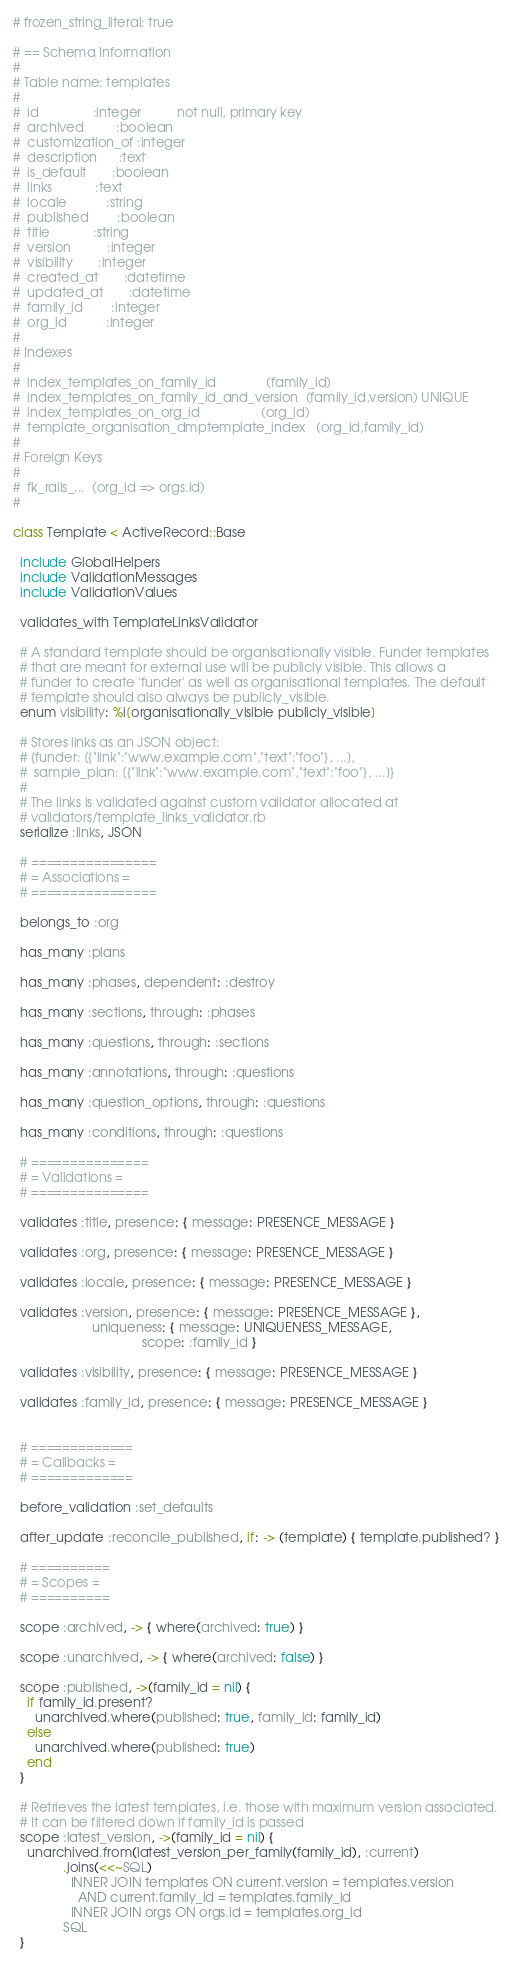<code> <loc_0><loc_0><loc_500><loc_500><_Ruby_># frozen_string_literal: true

# == Schema Information
#
# Table name: templates
#
#  id               :integer          not null, primary key
#  archived         :boolean
#  customization_of :integer
#  description      :text
#  is_default       :boolean
#  links            :text
#  locale           :string
#  published        :boolean
#  title            :string
#  version          :integer
#  visibility       :integer
#  created_at       :datetime
#  updated_at       :datetime
#  family_id        :integer
#  org_id           :integer
#
# Indexes
#
#  index_templates_on_family_id              (family_id)
#  index_templates_on_family_id_and_version  (family_id,version) UNIQUE
#  index_templates_on_org_id                 (org_id)
#  template_organisation_dmptemplate_index   (org_id,family_id)
#
# Foreign Keys
#
#  fk_rails_...  (org_id => orgs.id)
#

class Template < ActiveRecord::Base

  include GlobalHelpers
  include ValidationMessages
  include ValidationValues

  validates_with TemplateLinksValidator

  # A standard template should be organisationally visible. Funder templates
  # that are meant for external use will be publicly visible. This allows a
  # funder to create 'funder' as well as organisational templates. The default
  # template should also always be publicly_visible.
  enum visibility: %i[organisationally_visible publicly_visible]

  # Stores links as an JSON object:
  # {funder: [{"link":"www.example.com","text":"foo"}, ...],
  #  sample_plan: [{"link":"www.example.com","text":"foo"}, ...]}
  #
  # The links is validated against custom validator allocated at
  # validators/template_links_validator.rb
  serialize :links, JSON

  # ================
  # = Associations =
  # ================

  belongs_to :org

  has_many :plans

  has_many :phases, dependent: :destroy

  has_many :sections, through: :phases

  has_many :questions, through: :sections

  has_many :annotations, through: :questions

  has_many :question_options, through: :questions

  has_many :conditions, through: :questions

  # ===============
  # = Validations =
  # ===============

  validates :title, presence: { message: PRESENCE_MESSAGE }

  validates :org, presence: { message: PRESENCE_MESSAGE }

  validates :locale, presence: { message: PRESENCE_MESSAGE }

  validates :version, presence: { message: PRESENCE_MESSAGE },
                      uniqueness: { message: UNIQUENESS_MESSAGE,
                                    scope: :family_id }

  validates :visibility, presence: { message: PRESENCE_MESSAGE }

  validates :family_id, presence: { message: PRESENCE_MESSAGE }


  # =============
  # = Callbacks =
  # =============

  before_validation :set_defaults

  after_update :reconcile_published, if: -> (template) { template.published? }

  # ==========
  # = Scopes =
  # ==========

  scope :archived, -> { where(archived: true) }

  scope :unarchived, -> { where(archived: false) }

  scope :published, ->(family_id = nil) {
    if family_id.present?
      unarchived.where(published: true, family_id: family_id)
    else
      unarchived.where(published: true)
    end
  }

  # Retrieves the latest templates, i.e. those with maximum version associated.
  # It can be filtered down if family_id is passed
  scope :latest_version, ->(family_id = nil) {
    unarchived.from(latest_version_per_family(family_id), :current)
              .joins(<<~SQL)
                INNER JOIN templates ON current.version = templates.version
                  AND current.family_id = templates.family_id
                INNER JOIN orgs ON orgs.id = templates.org_id
              SQL
  }
</code> 